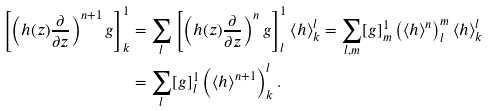<formula> <loc_0><loc_0><loc_500><loc_500>\left [ \left ( h ( z ) \frac { \partial } { \partial z } \right ) ^ { n + 1 } g \right ] ^ { 1 } _ { k } & = \sum _ { l } \left [ \left ( h ( z ) \frac { \partial } { \partial z } \right ) ^ { n } g \right ] ^ { 1 } _ { l } \left < h \right > ^ { l } _ { k } = \sum _ { l , m } [ g ] ^ { 1 } _ { m } \left ( \left < h \right > ^ { n } \right ) ^ { m } _ { l } \left < h \right > ^ { l } _ { k } \\ & = \sum _ { l } [ g ] ^ { 1 } _ { l } \left ( \left < h \right > ^ { n + 1 } \right ) ^ { l } _ { k } . \\</formula> 